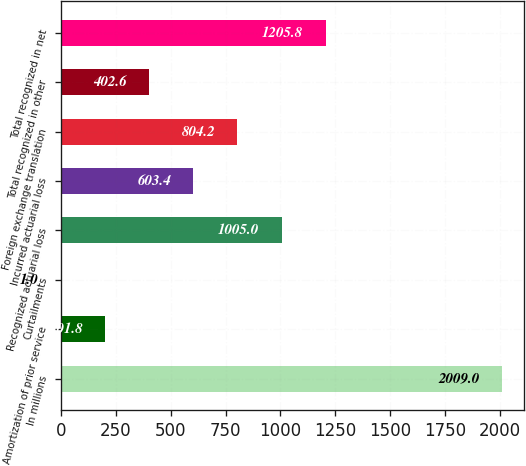Convert chart. <chart><loc_0><loc_0><loc_500><loc_500><bar_chart><fcel>In millions<fcel>Amortization of prior service<fcel>Curtailments<fcel>Recognized actuarial loss<fcel>Incurred actuarial loss<fcel>Foreign exchange translation<fcel>Total recognized in other<fcel>Total recognized in net<nl><fcel>2009<fcel>201.8<fcel>1<fcel>1005<fcel>603.4<fcel>804.2<fcel>402.6<fcel>1205.8<nl></chart> 